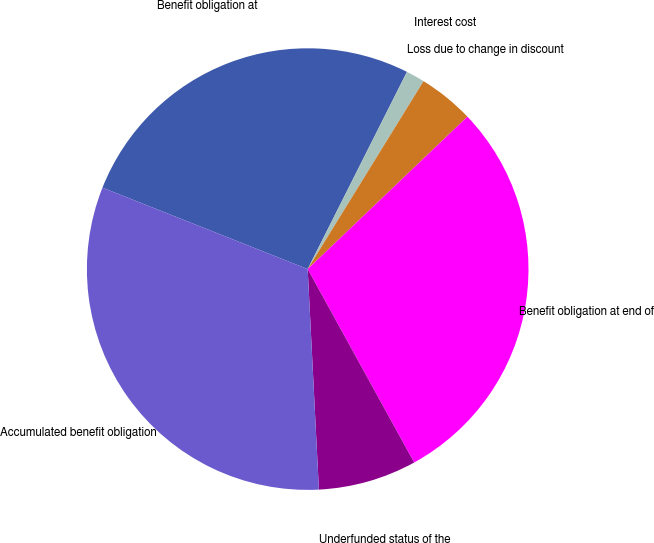Convert chart. <chart><loc_0><loc_0><loc_500><loc_500><pie_chart><fcel>Benefit obligation at<fcel>Interest cost<fcel>Loss due to change in discount<fcel>Benefit obligation at end of<fcel>Underfunded status of the<fcel>Accumulated benefit obligation<nl><fcel>26.41%<fcel>1.37%<fcel>4.08%<fcel>29.12%<fcel>7.2%<fcel>31.82%<nl></chart> 